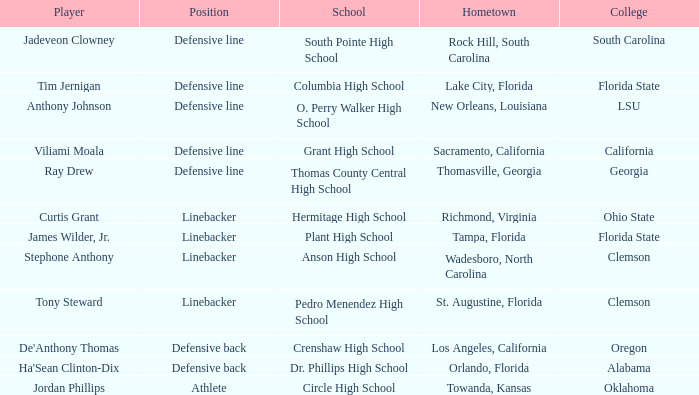Help me parse the entirety of this table. {'header': ['Player', 'Position', 'School', 'Hometown', 'College'], 'rows': [['Jadeveon Clowney', 'Defensive line', 'South Pointe High School', 'Rock Hill, South Carolina', 'South Carolina'], ['Tim Jernigan', 'Defensive line', 'Columbia High School', 'Lake City, Florida', 'Florida State'], ['Anthony Johnson', 'Defensive line', 'O. Perry Walker High School', 'New Orleans, Louisiana', 'LSU'], ['Viliami Moala', 'Defensive line', 'Grant High School', 'Sacramento, California', 'California'], ['Ray Drew', 'Defensive line', 'Thomas County Central High School', 'Thomasville, Georgia', 'Georgia'], ['Curtis Grant', 'Linebacker', 'Hermitage High School', 'Richmond, Virginia', 'Ohio State'], ['James Wilder, Jr.', 'Linebacker', 'Plant High School', 'Tampa, Florida', 'Florida State'], ['Stephone Anthony', 'Linebacker', 'Anson High School', 'Wadesboro, North Carolina', 'Clemson'], ['Tony Steward', 'Linebacker', 'Pedro Menendez High School', 'St. Augustine, Florida', 'Clemson'], ["De'Anthony Thomas", 'Defensive back', 'Crenshaw High School', 'Los Angeles, California', 'Oregon'], ["Ha'Sean Clinton-Dix", 'Defensive back', 'Dr. Phillips High School', 'Orlando, Florida', 'Alabama'], ['Jordan Phillips', 'Athlete', 'Circle High School', 'Towanda, Kansas', 'Oklahoma']]} What position is for Plant high school? Linebacker. 